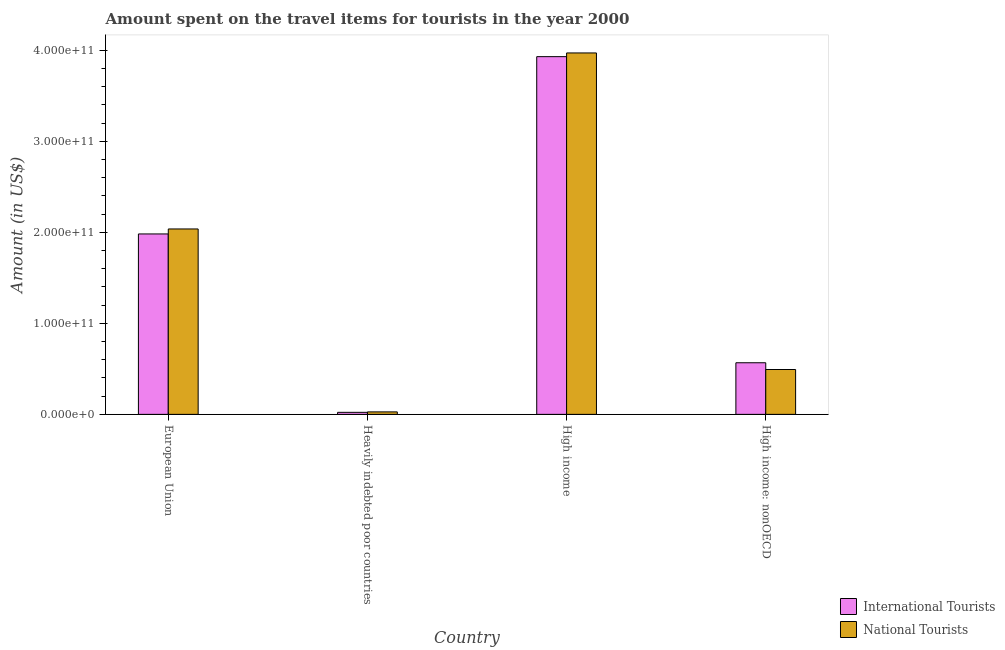How many different coloured bars are there?
Make the answer very short. 2. What is the label of the 4th group of bars from the left?
Offer a very short reply. High income: nonOECD. What is the amount spent on travel items of national tourists in High income?
Your response must be concise. 3.97e+11. Across all countries, what is the maximum amount spent on travel items of national tourists?
Ensure brevity in your answer.  3.97e+11. Across all countries, what is the minimum amount spent on travel items of national tourists?
Your answer should be compact. 2.72e+09. In which country was the amount spent on travel items of national tourists minimum?
Make the answer very short. Heavily indebted poor countries. What is the total amount spent on travel items of national tourists in the graph?
Make the answer very short. 6.53e+11. What is the difference between the amount spent on travel items of international tourists in European Union and that in Heavily indebted poor countries?
Your answer should be compact. 1.96e+11. What is the difference between the amount spent on travel items of national tourists in Heavily indebted poor countries and the amount spent on travel items of international tourists in High income: nonOECD?
Offer a terse response. -5.40e+1. What is the average amount spent on travel items of international tourists per country?
Provide a succinct answer. 1.63e+11. What is the difference between the amount spent on travel items of national tourists and amount spent on travel items of international tourists in High income: nonOECD?
Provide a succinct answer. -7.42e+09. In how many countries, is the amount spent on travel items of national tourists greater than 180000000000 US$?
Ensure brevity in your answer.  2. What is the ratio of the amount spent on travel items of international tourists in Heavily indebted poor countries to that in High income: nonOECD?
Provide a succinct answer. 0.04. Is the difference between the amount spent on travel items of international tourists in European Union and Heavily indebted poor countries greater than the difference between the amount spent on travel items of national tourists in European Union and Heavily indebted poor countries?
Offer a very short reply. No. What is the difference between the highest and the second highest amount spent on travel items of international tourists?
Offer a terse response. 1.95e+11. What is the difference between the highest and the lowest amount spent on travel items of international tourists?
Keep it short and to the point. 3.91e+11. In how many countries, is the amount spent on travel items of international tourists greater than the average amount spent on travel items of international tourists taken over all countries?
Your answer should be very brief. 2. Is the sum of the amount spent on travel items of international tourists in Heavily indebted poor countries and High income: nonOECD greater than the maximum amount spent on travel items of national tourists across all countries?
Provide a short and direct response. No. What does the 2nd bar from the left in European Union represents?
Offer a terse response. National Tourists. What does the 2nd bar from the right in High income: nonOECD represents?
Your answer should be compact. International Tourists. Are all the bars in the graph horizontal?
Your response must be concise. No. How many countries are there in the graph?
Provide a succinct answer. 4. What is the difference between two consecutive major ticks on the Y-axis?
Ensure brevity in your answer.  1.00e+11. Are the values on the major ticks of Y-axis written in scientific E-notation?
Offer a terse response. Yes. Does the graph contain grids?
Provide a succinct answer. No. Where does the legend appear in the graph?
Offer a terse response. Bottom right. What is the title of the graph?
Provide a short and direct response. Amount spent on the travel items for tourists in the year 2000. Does "Grants" appear as one of the legend labels in the graph?
Keep it short and to the point. No. What is the label or title of the X-axis?
Your answer should be very brief. Country. What is the Amount (in US$) in International Tourists in European Union?
Ensure brevity in your answer.  1.98e+11. What is the Amount (in US$) of National Tourists in European Union?
Offer a terse response. 2.04e+11. What is the Amount (in US$) of International Tourists in Heavily indebted poor countries?
Offer a terse response. 2.24e+09. What is the Amount (in US$) in National Tourists in Heavily indebted poor countries?
Offer a very short reply. 2.72e+09. What is the Amount (in US$) of International Tourists in High income?
Offer a terse response. 3.93e+11. What is the Amount (in US$) of National Tourists in High income?
Offer a very short reply. 3.97e+11. What is the Amount (in US$) of International Tourists in High income: nonOECD?
Provide a succinct answer. 5.67e+1. What is the Amount (in US$) in National Tourists in High income: nonOECD?
Your answer should be very brief. 4.93e+1. Across all countries, what is the maximum Amount (in US$) of International Tourists?
Provide a short and direct response. 3.93e+11. Across all countries, what is the maximum Amount (in US$) in National Tourists?
Offer a terse response. 3.97e+11. Across all countries, what is the minimum Amount (in US$) of International Tourists?
Keep it short and to the point. 2.24e+09. Across all countries, what is the minimum Amount (in US$) in National Tourists?
Keep it short and to the point. 2.72e+09. What is the total Amount (in US$) of International Tourists in the graph?
Your response must be concise. 6.50e+11. What is the total Amount (in US$) of National Tourists in the graph?
Your answer should be compact. 6.53e+11. What is the difference between the Amount (in US$) in International Tourists in European Union and that in Heavily indebted poor countries?
Provide a short and direct response. 1.96e+11. What is the difference between the Amount (in US$) of National Tourists in European Union and that in Heavily indebted poor countries?
Ensure brevity in your answer.  2.01e+11. What is the difference between the Amount (in US$) in International Tourists in European Union and that in High income?
Your answer should be very brief. -1.95e+11. What is the difference between the Amount (in US$) of National Tourists in European Union and that in High income?
Your answer should be compact. -1.93e+11. What is the difference between the Amount (in US$) of International Tourists in European Union and that in High income: nonOECD?
Give a very brief answer. 1.41e+11. What is the difference between the Amount (in US$) of National Tourists in European Union and that in High income: nonOECD?
Offer a terse response. 1.54e+11. What is the difference between the Amount (in US$) in International Tourists in Heavily indebted poor countries and that in High income?
Your answer should be compact. -3.91e+11. What is the difference between the Amount (in US$) of National Tourists in Heavily indebted poor countries and that in High income?
Give a very brief answer. -3.94e+11. What is the difference between the Amount (in US$) of International Tourists in Heavily indebted poor countries and that in High income: nonOECD?
Provide a succinct answer. -5.45e+1. What is the difference between the Amount (in US$) of National Tourists in Heavily indebted poor countries and that in High income: nonOECD?
Provide a succinct answer. -4.66e+1. What is the difference between the Amount (in US$) in International Tourists in High income and that in High income: nonOECD?
Your answer should be very brief. 3.36e+11. What is the difference between the Amount (in US$) of National Tourists in High income and that in High income: nonOECD?
Keep it short and to the point. 3.48e+11. What is the difference between the Amount (in US$) of International Tourists in European Union and the Amount (in US$) of National Tourists in Heavily indebted poor countries?
Ensure brevity in your answer.  1.95e+11. What is the difference between the Amount (in US$) in International Tourists in European Union and the Amount (in US$) in National Tourists in High income?
Offer a terse response. -1.99e+11. What is the difference between the Amount (in US$) in International Tourists in European Union and the Amount (in US$) in National Tourists in High income: nonOECD?
Ensure brevity in your answer.  1.49e+11. What is the difference between the Amount (in US$) in International Tourists in Heavily indebted poor countries and the Amount (in US$) in National Tourists in High income?
Your answer should be compact. -3.95e+11. What is the difference between the Amount (in US$) in International Tourists in Heavily indebted poor countries and the Amount (in US$) in National Tourists in High income: nonOECD?
Offer a terse response. -4.70e+1. What is the difference between the Amount (in US$) of International Tourists in High income and the Amount (in US$) of National Tourists in High income: nonOECD?
Keep it short and to the point. 3.44e+11. What is the average Amount (in US$) of International Tourists per country?
Offer a very short reply. 1.63e+11. What is the average Amount (in US$) of National Tourists per country?
Provide a short and direct response. 1.63e+11. What is the difference between the Amount (in US$) in International Tourists and Amount (in US$) in National Tourists in European Union?
Ensure brevity in your answer.  -5.48e+09. What is the difference between the Amount (in US$) of International Tourists and Amount (in US$) of National Tourists in Heavily indebted poor countries?
Provide a succinct answer. -4.82e+08. What is the difference between the Amount (in US$) of International Tourists and Amount (in US$) of National Tourists in High income?
Your response must be concise. -4.06e+09. What is the difference between the Amount (in US$) of International Tourists and Amount (in US$) of National Tourists in High income: nonOECD?
Keep it short and to the point. 7.42e+09. What is the ratio of the Amount (in US$) in International Tourists in European Union to that in Heavily indebted poor countries?
Provide a succinct answer. 88.62. What is the ratio of the Amount (in US$) in National Tourists in European Union to that in Heavily indebted poor countries?
Offer a very short reply. 74.93. What is the ratio of the Amount (in US$) of International Tourists in European Union to that in High income?
Your response must be concise. 0.5. What is the ratio of the Amount (in US$) in National Tourists in European Union to that in High income?
Keep it short and to the point. 0.51. What is the ratio of the Amount (in US$) in International Tourists in European Union to that in High income: nonOECD?
Provide a succinct answer. 3.5. What is the ratio of the Amount (in US$) in National Tourists in European Union to that in High income: nonOECD?
Make the answer very short. 4.13. What is the ratio of the Amount (in US$) in International Tourists in Heavily indebted poor countries to that in High income?
Give a very brief answer. 0.01. What is the ratio of the Amount (in US$) in National Tourists in Heavily indebted poor countries to that in High income?
Give a very brief answer. 0.01. What is the ratio of the Amount (in US$) of International Tourists in Heavily indebted poor countries to that in High income: nonOECD?
Give a very brief answer. 0.04. What is the ratio of the Amount (in US$) of National Tourists in Heavily indebted poor countries to that in High income: nonOECD?
Offer a very short reply. 0.06. What is the ratio of the Amount (in US$) in International Tourists in High income to that in High income: nonOECD?
Give a very brief answer. 6.93. What is the ratio of the Amount (in US$) in National Tourists in High income to that in High income: nonOECD?
Make the answer very short. 8.05. What is the difference between the highest and the second highest Amount (in US$) of International Tourists?
Your answer should be very brief. 1.95e+11. What is the difference between the highest and the second highest Amount (in US$) in National Tourists?
Offer a very short reply. 1.93e+11. What is the difference between the highest and the lowest Amount (in US$) of International Tourists?
Make the answer very short. 3.91e+11. What is the difference between the highest and the lowest Amount (in US$) in National Tourists?
Your response must be concise. 3.94e+11. 